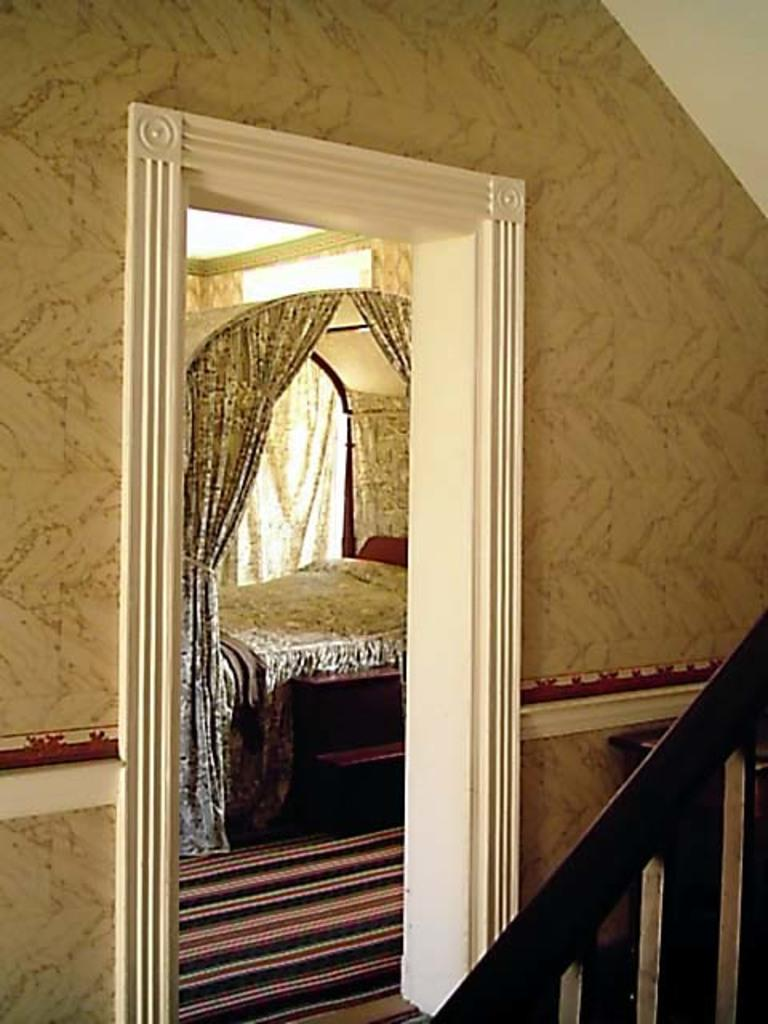What type of furniture is present in the picture? There is a bed in the picture. What type of window treatment is visible in the picture? There are curtains in the picture. What type of architectural feature is present in the picture? There is a wall in the picture. What type of berry is being used as a pillow on the bed in the picture? There is no berry present in the picture, and the bed does not have a pillow made of berries. Can you see a plane flying in the sky in the picture? There is no plane visible in the picture, as it only features a bed, curtains, and a wall. 